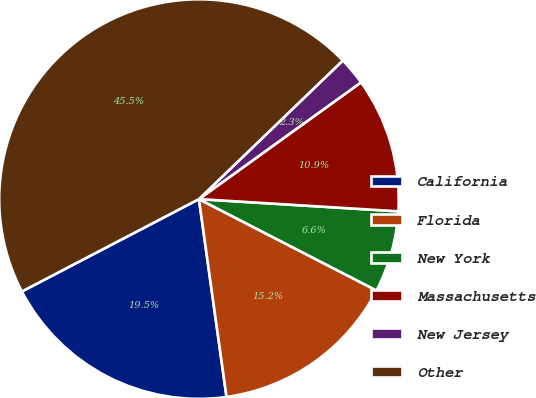<chart> <loc_0><loc_0><loc_500><loc_500><pie_chart><fcel>California<fcel>Florida<fcel>New York<fcel>Massachusetts<fcel>New Jersey<fcel>Other<nl><fcel>19.55%<fcel>15.23%<fcel>6.59%<fcel>10.91%<fcel>2.27%<fcel>45.45%<nl></chart> 